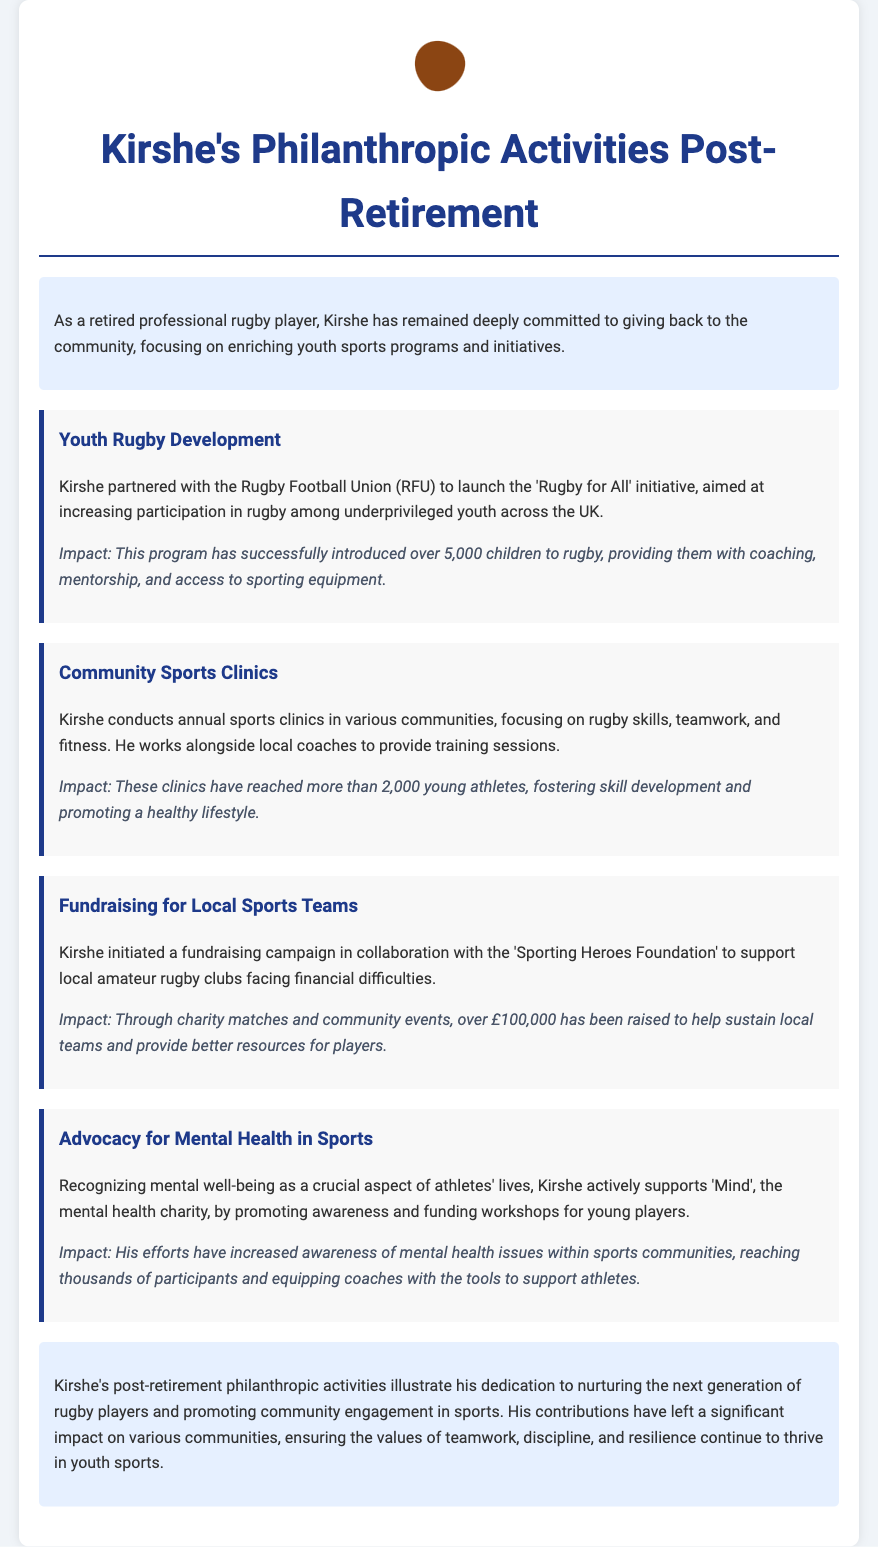What is the name of the initiative Kirshe partnered with the RFU? The initiative launched by Kirshe in partnership with the RFU is named 'Rugby for All'.
Answer: 'Rugby for All' How many children have been introduced to rugby through the 'Rugby for All' initiative? The program has successfully introduced over 5,000 children to rugby.
Answer: Over 5,000 What is the main focus of Kirshe's annual sports clinics? Kirshe's annual sports clinics focus on rugby skills, teamwork, and fitness.
Answer: Rugby skills, teamwork, and fitness How much money has been raised to support local amateur rugby clubs? Kirshe's fundraising campaign has raised over £100,000.
Answer: Over £100,000 What mental health charity does Kirshe actively support? Kirshe actively supports the mental health charity 'Mind'.
Answer: Mind Why are Kirshe's philanthropic activities significant? Kirshe's activities are significant as they nurture the next generation of rugby players and promote community engagement in sports.
Answer: Nurturing the next generation of rugby players and promoting community engagement in sports What is the impact of Kirshe's advocacy for mental health in sports? His efforts have increased awareness of mental health issues within sports communities, reaching thousands of participants.
Answer: Increased awareness of mental health issues What institution does Kirshe collaborate with for youth rugby development? Kirshe collaborates with the Rugby Football Union (RFU).
Answer: Rugby Football Union (RFU) How many young athletes have attended Kirshe's sports clinics? The clinics have reached more than 2,000 young athletes.
Answer: More than 2,000 